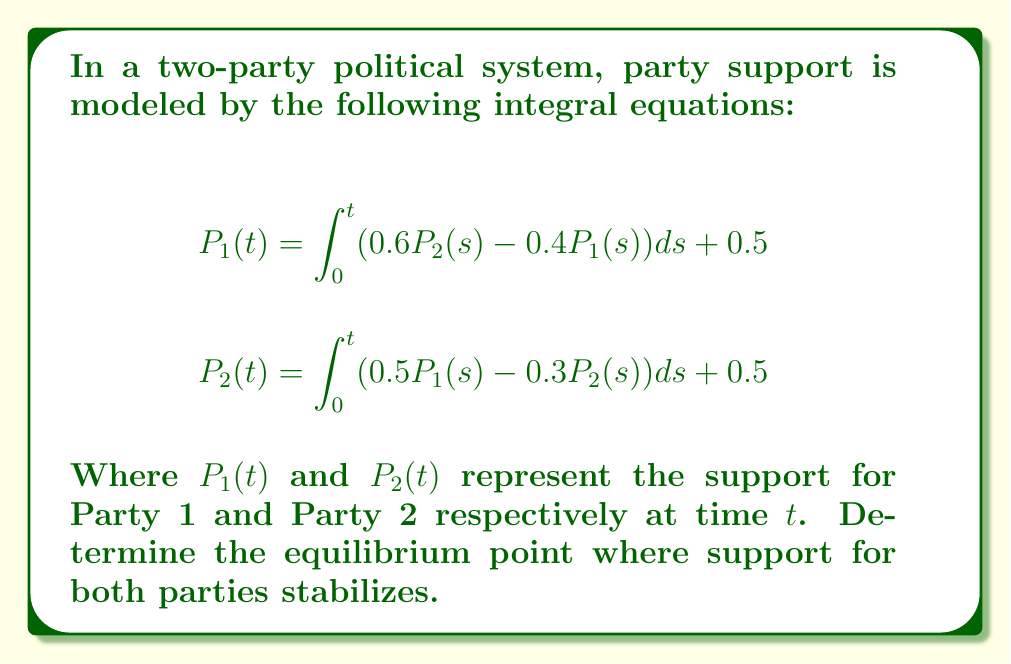Help me with this question. To find the equilibrium point, we need to follow these steps:

1) At equilibrium, the support levels don't change with time. This means:

   $$\frac{dP_1}{dt} = \frac{dP_2}{dt} = 0$$

2) Differentiate both equations with respect to $t$:

   $$\frac{dP_1}{dt} = 0.6P_2 - 0.4P_1$$
   $$\frac{dP_2}{dt} = 0.5P_1 - 0.3P_2$$

3) Set both equations to zero for equilibrium:

   $$0 = 0.6P_2 - 0.4P_1$$
   $$0 = 0.5P_1 - 0.3P_2$$

4) From the first equation:
   $$P_2 = \frac{2}{3}P_1$$

5) Substitute this into the second equation:

   $$0 = 0.5P_1 - 0.3(\frac{2}{3}P_1) = 0.5P_1 - 0.2P_1 = 0.3P_1$$

6) This is only true if $P_1 = 0$, but this doesn't satisfy our original equations which have a constant term of 0.5.

7) Therefore, we need to consider the constant terms. At equilibrium:

   $$P_1 = 0.6P_2 - 0.4P_1 + 0.5$$
   $$P_2 = 0.5P_1 - 0.3P_2 + 0.5$$

8) Solve this system of equations:
   $$1.4P_1 = 0.6P_2 + 0.5$$
   $$1.3P_2 = 0.5P_1 + 0.5$$

9) Multiply the first equation by 1.3 and the second by 0.6:
   $$1.82P_1 = 0.78P_2 + 0.65$$
   $$0.78P_2 = 0.3P_1 + 0.3$$

10) Subtract the second equation from the first:
    $$1.52P_1 = 0.35$$

11) Therefore:
    $$P_1 = \frac{0.35}{1.52} \approx 0.2303$$

12) Substitute this back into equation from step 4:
    $$P_2 = \frac{2}{3} * 0.2303 \approx 0.1535$$

Thus, the equilibrium point is approximately (0.2303, 0.1535).
Answer: (0.2303, 0.1535) 